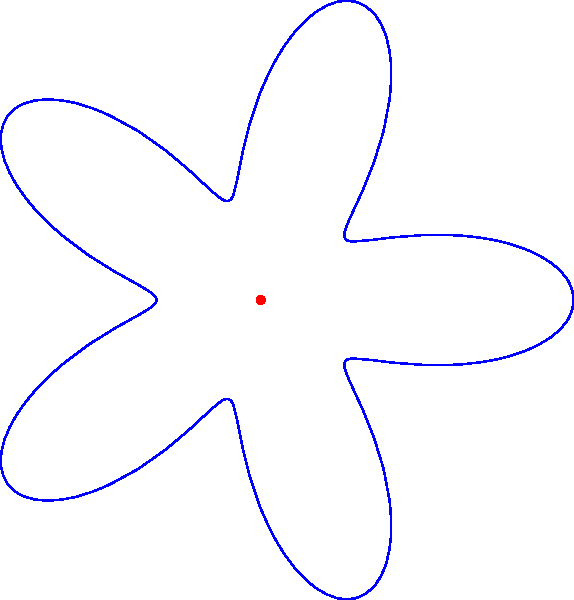Look at this pretty flower shape! Can you count how many petals it has? Let's count the petals together:

1. Start at the top of the flower and move clockwise.
2. Each "bump" or point that sticks out is a petal.
3. Count each petal as you go around:
   - First petal at the top
   - Second petal to the right
   - Third petal at the bottom right
   - Fourth petal at the bottom left
   - Fifth petal to the left

4. We've gone all the way around and counted 5 petals in total.

The number of petals in a polar graph like this is determined by the coefficient of $t$ in the cosine function. In this case, it's $\cos(5t)$, which gives us 5 petals.
Answer: 5 petals 